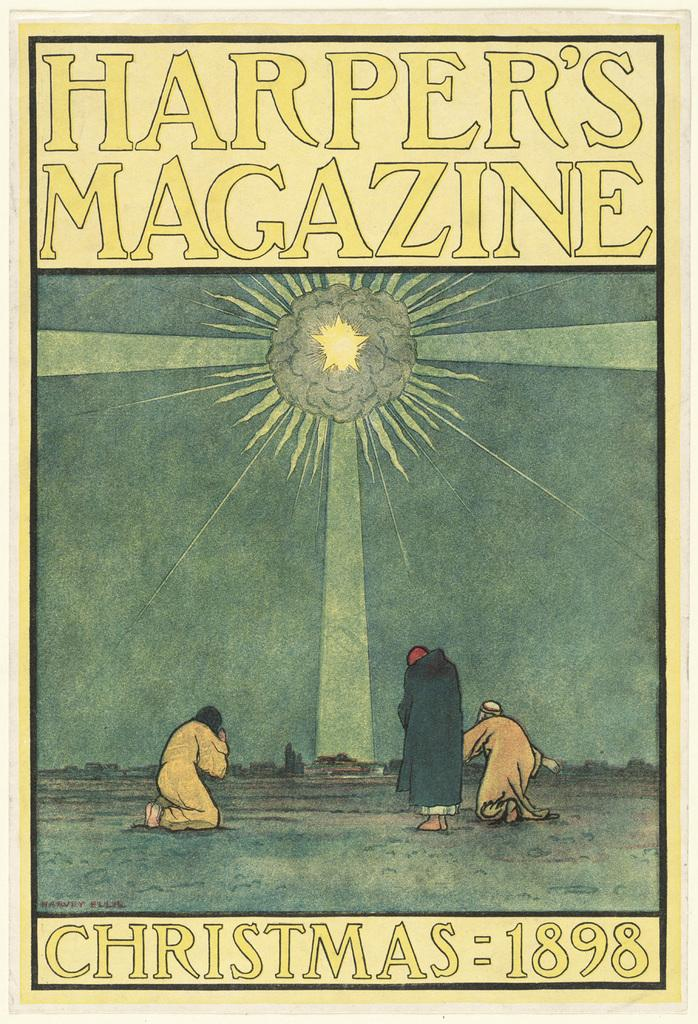What is present in the image that features visual content? There is a poster in the image. What can be seen on the poster? The poster contains images of three persons. Are there any words or phrases on the poster? Yes, there is edited text on the poster. What is the color of the edited text on the poster? The edited text is in yellow color. What type of furniture is visible in the image? There is no furniture present in the image; it only features a poster. Is there any mention of payment on the poster? There is no mention of payment on the poster; it only contains images of three persons and edited text. 